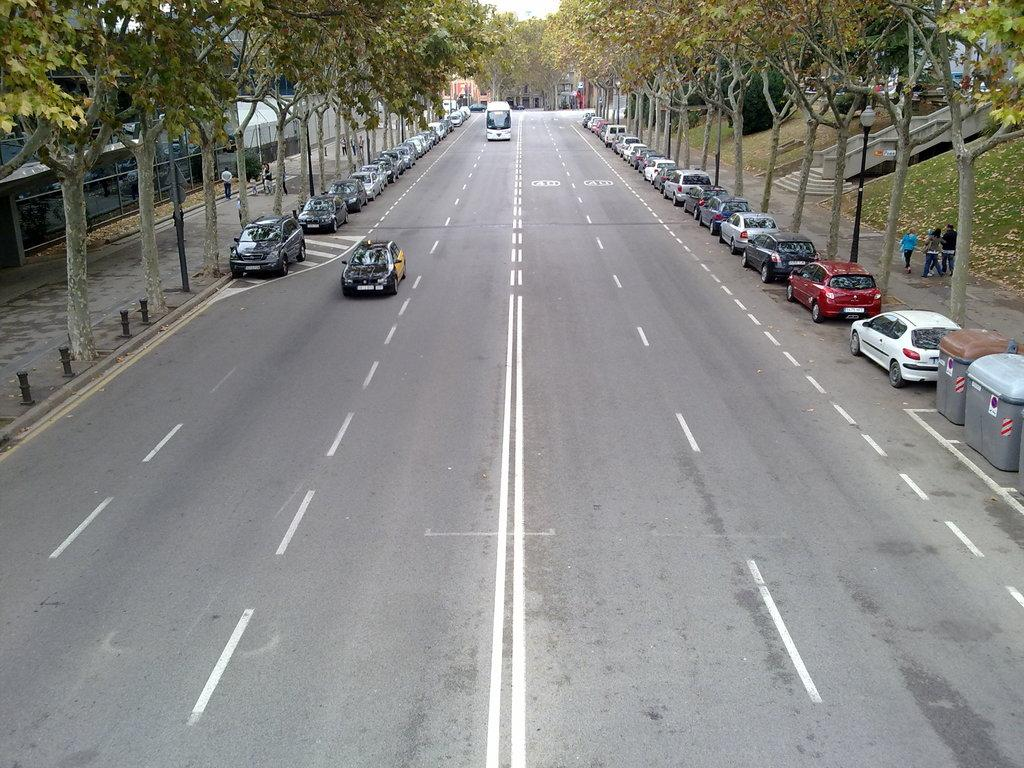What types of objects are on the ground in the image? There are vehicles on the ground in the image. What can be found near the vehicles on the ground? Dustbins are present in the image. What natural elements can be seen in the image? Trees are visible in the image. What structure is present in the image to provide light? There is a light pole in the image. What type of information might be conveyed by the sign board in the image? The sign board in the image might convey information about directions, rules, or advertisements. What is present on the ground in the image besides vehicles? There are leaves on the ground in the image. What type of man-made structures can be seen in the image? There are buildings in the image. How many hens are sitting on the light pole in the image? There are no hens present in the image; the light pole is a structure for providing light. What type of bone can be seen in the image? There is no bone present in the image. 